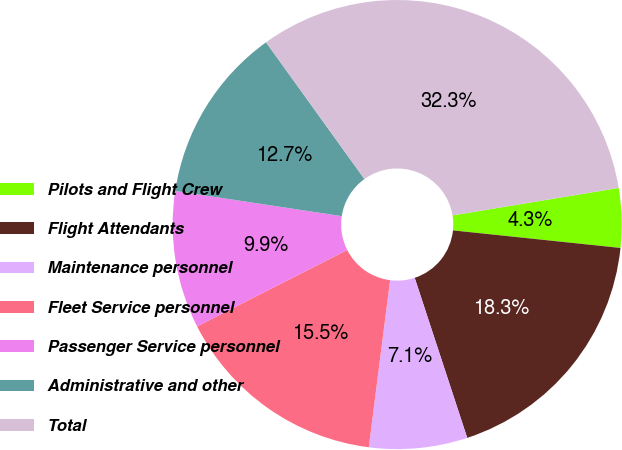<chart> <loc_0><loc_0><loc_500><loc_500><pie_chart><fcel>Pilots and Flight Crew<fcel>Flight Attendants<fcel>Maintenance personnel<fcel>Fleet Service personnel<fcel>Passenger Service personnel<fcel>Administrative and other<fcel>Total<nl><fcel>4.27%<fcel>18.29%<fcel>7.07%<fcel>15.49%<fcel>9.88%<fcel>12.68%<fcel>32.32%<nl></chart> 